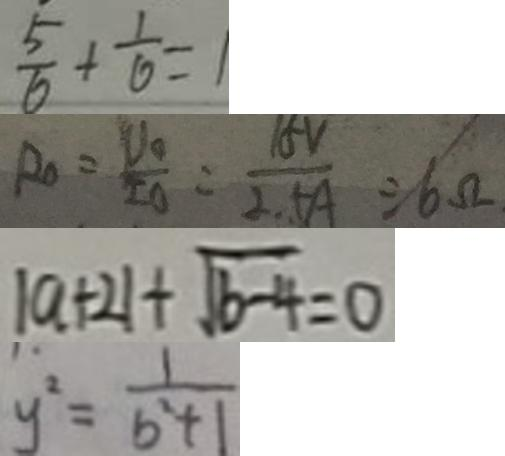<formula> <loc_0><loc_0><loc_500><loc_500>\frac { 5 } { 6 } + \frac { 1 } { 6 } = 1 
 R _ { 0 } = \frac { V _ { 0 } } { I _ { 0 } } = \frac { 1 5 V } { 2 . 5 A } = 6 . \Omega 
 \vert a + 2 \vert + \sqrt { b - 4 } = 0 
 y ^ { 2 } = \frac { 1 } { b ^ { 2 } + 1 }</formula> 